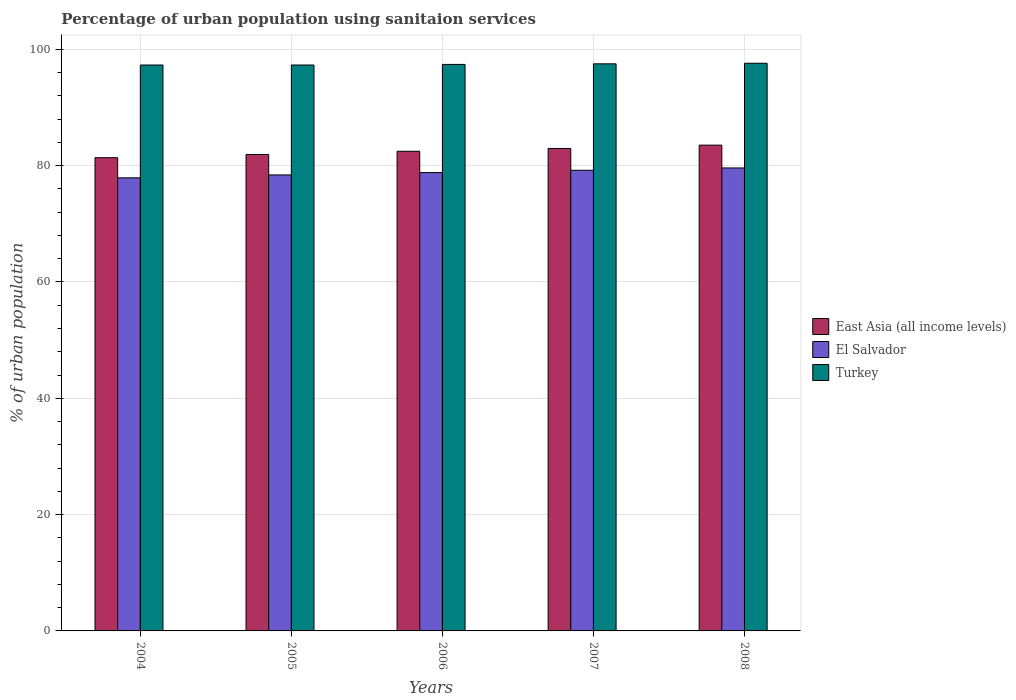How many different coloured bars are there?
Ensure brevity in your answer.  3. Are the number of bars per tick equal to the number of legend labels?
Offer a terse response. Yes. What is the percentage of urban population using sanitaion services in El Salvador in 2007?
Your answer should be very brief. 79.2. Across all years, what is the maximum percentage of urban population using sanitaion services in East Asia (all income levels)?
Keep it short and to the point. 83.52. Across all years, what is the minimum percentage of urban population using sanitaion services in Turkey?
Your response must be concise. 97.3. In which year was the percentage of urban population using sanitaion services in Turkey maximum?
Give a very brief answer. 2008. What is the total percentage of urban population using sanitaion services in East Asia (all income levels) in the graph?
Keep it short and to the point. 412.21. What is the difference between the percentage of urban population using sanitaion services in Turkey in 2007 and that in 2008?
Offer a terse response. -0.1. What is the difference between the percentage of urban population using sanitaion services in El Salvador in 2008 and the percentage of urban population using sanitaion services in East Asia (all income levels) in 2004?
Provide a succinct answer. -1.76. What is the average percentage of urban population using sanitaion services in East Asia (all income levels) per year?
Provide a succinct answer. 82.44. In the year 2005, what is the difference between the percentage of urban population using sanitaion services in Turkey and percentage of urban population using sanitaion services in East Asia (all income levels)?
Provide a succinct answer. 15.39. In how many years, is the percentage of urban population using sanitaion services in Turkey greater than 28 %?
Make the answer very short. 5. What is the ratio of the percentage of urban population using sanitaion services in East Asia (all income levels) in 2004 to that in 2008?
Make the answer very short. 0.97. Is the percentage of urban population using sanitaion services in El Salvador in 2004 less than that in 2007?
Provide a succinct answer. Yes. Is the difference between the percentage of urban population using sanitaion services in Turkey in 2006 and 2008 greater than the difference between the percentage of urban population using sanitaion services in East Asia (all income levels) in 2006 and 2008?
Ensure brevity in your answer.  Yes. What is the difference between the highest and the second highest percentage of urban population using sanitaion services in East Asia (all income levels)?
Your answer should be compact. 0.57. What is the difference between the highest and the lowest percentage of urban population using sanitaion services in Turkey?
Make the answer very short. 0.3. Is the sum of the percentage of urban population using sanitaion services in East Asia (all income levels) in 2005 and 2008 greater than the maximum percentage of urban population using sanitaion services in Turkey across all years?
Ensure brevity in your answer.  Yes. What does the 1st bar from the left in 2005 represents?
Your response must be concise. East Asia (all income levels). What does the 3rd bar from the right in 2005 represents?
Give a very brief answer. East Asia (all income levels). Are all the bars in the graph horizontal?
Your answer should be very brief. No. What is the difference between two consecutive major ticks on the Y-axis?
Your response must be concise. 20. How are the legend labels stacked?
Your response must be concise. Vertical. What is the title of the graph?
Provide a succinct answer. Percentage of urban population using sanitaion services. Does "San Marino" appear as one of the legend labels in the graph?
Keep it short and to the point. No. What is the label or title of the Y-axis?
Provide a short and direct response. % of urban population. What is the % of urban population of East Asia (all income levels) in 2004?
Keep it short and to the point. 81.36. What is the % of urban population of El Salvador in 2004?
Keep it short and to the point. 77.9. What is the % of urban population in Turkey in 2004?
Keep it short and to the point. 97.3. What is the % of urban population in East Asia (all income levels) in 2005?
Your answer should be compact. 81.91. What is the % of urban population in El Salvador in 2005?
Ensure brevity in your answer.  78.4. What is the % of urban population in Turkey in 2005?
Offer a terse response. 97.3. What is the % of urban population in East Asia (all income levels) in 2006?
Offer a very short reply. 82.47. What is the % of urban population in El Salvador in 2006?
Provide a succinct answer. 78.8. What is the % of urban population of Turkey in 2006?
Give a very brief answer. 97.4. What is the % of urban population of East Asia (all income levels) in 2007?
Offer a very short reply. 82.95. What is the % of urban population of El Salvador in 2007?
Your response must be concise. 79.2. What is the % of urban population in Turkey in 2007?
Your answer should be very brief. 97.5. What is the % of urban population in East Asia (all income levels) in 2008?
Provide a succinct answer. 83.52. What is the % of urban population in El Salvador in 2008?
Give a very brief answer. 79.6. What is the % of urban population in Turkey in 2008?
Your response must be concise. 97.6. Across all years, what is the maximum % of urban population of East Asia (all income levels)?
Offer a very short reply. 83.52. Across all years, what is the maximum % of urban population in El Salvador?
Ensure brevity in your answer.  79.6. Across all years, what is the maximum % of urban population of Turkey?
Provide a succinct answer. 97.6. Across all years, what is the minimum % of urban population of East Asia (all income levels)?
Offer a terse response. 81.36. Across all years, what is the minimum % of urban population of El Salvador?
Provide a short and direct response. 77.9. Across all years, what is the minimum % of urban population in Turkey?
Your answer should be compact. 97.3. What is the total % of urban population in East Asia (all income levels) in the graph?
Offer a very short reply. 412.21. What is the total % of urban population in El Salvador in the graph?
Make the answer very short. 393.9. What is the total % of urban population of Turkey in the graph?
Your answer should be very brief. 487.1. What is the difference between the % of urban population of East Asia (all income levels) in 2004 and that in 2005?
Ensure brevity in your answer.  -0.55. What is the difference between the % of urban population of El Salvador in 2004 and that in 2005?
Ensure brevity in your answer.  -0.5. What is the difference between the % of urban population in East Asia (all income levels) in 2004 and that in 2006?
Ensure brevity in your answer.  -1.11. What is the difference between the % of urban population in El Salvador in 2004 and that in 2006?
Your response must be concise. -0.9. What is the difference between the % of urban population in Turkey in 2004 and that in 2006?
Keep it short and to the point. -0.1. What is the difference between the % of urban population in East Asia (all income levels) in 2004 and that in 2007?
Give a very brief answer. -1.59. What is the difference between the % of urban population of East Asia (all income levels) in 2004 and that in 2008?
Keep it short and to the point. -2.16. What is the difference between the % of urban population in El Salvador in 2004 and that in 2008?
Provide a succinct answer. -1.7. What is the difference between the % of urban population of Turkey in 2004 and that in 2008?
Provide a short and direct response. -0.3. What is the difference between the % of urban population of East Asia (all income levels) in 2005 and that in 2006?
Provide a short and direct response. -0.55. What is the difference between the % of urban population of East Asia (all income levels) in 2005 and that in 2007?
Ensure brevity in your answer.  -1.04. What is the difference between the % of urban population of Turkey in 2005 and that in 2007?
Your response must be concise. -0.2. What is the difference between the % of urban population in East Asia (all income levels) in 2005 and that in 2008?
Provide a short and direct response. -1.61. What is the difference between the % of urban population in Turkey in 2005 and that in 2008?
Provide a short and direct response. -0.3. What is the difference between the % of urban population of East Asia (all income levels) in 2006 and that in 2007?
Provide a short and direct response. -0.49. What is the difference between the % of urban population in East Asia (all income levels) in 2006 and that in 2008?
Offer a very short reply. -1.05. What is the difference between the % of urban population in East Asia (all income levels) in 2007 and that in 2008?
Make the answer very short. -0.57. What is the difference between the % of urban population of El Salvador in 2007 and that in 2008?
Give a very brief answer. -0.4. What is the difference between the % of urban population of Turkey in 2007 and that in 2008?
Offer a terse response. -0.1. What is the difference between the % of urban population in East Asia (all income levels) in 2004 and the % of urban population in El Salvador in 2005?
Your answer should be very brief. 2.96. What is the difference between the % of urban population of East Asia (all income levels) in 2004 and the % of urban population of Turkey in 2005?
Your answer should be very brief. -15.94. What is the difference between the % of urban population in El Salvador in 2004 and the % of urban population in Turkey in 2005?
Give a very brief answer. -19.4. What is the difference between the % of urban population of East Asia (all income levels) in 2004 and the % of urban population of El Salvador in 2006?
Keep it short and to the point. 2.56. What is the difference between the % of urban population of East Asia (all income levels) in 2004 and the % of urban population of Turkey in 2006?
Make the answer very short. -16.04. What is the difference between the % of urban population in El Salvador in 2004 and the % of urban population in Turkey in 2006?
Your answer should be compact. -19.5. What is the difference between the % of urban population of East Asia (all income levels) in 2004 and the % of urban population of El Salvador in 2007?
Ensure brevity in your answer.  2.16. What is the difference between the % of urban population of East Asia (all income levels) in 2004 and the % of urban population of Turkey in 2007?
Make the answer very short. -16.14. What is the difference between the % of urban population in El Salvador in 2004 and the % of urban population in Turkey in 2007?
Keep it short and to the point. -19.6. What is the difference between the % of urban population in East Asia (all income levels) in 2004 and the % of urban population in El Salvador in 2008?
Your response must be concise. 1.76. What is the difference between the % of urban population in East Asia (all income levels) in 2004 and the % of urban population in Turkey in 2008?
Offer a very short reply. -16.24. What is the difference between the % of urban population of El Salvador in 2004 and the % of urban population of Turkey in 2008?
Make the answer very short. -19.7. What is the difference between the % of urban population in East Asia (all income levels) in 2005 and the % of urban population in El Salvador in 2006?
Provide a succinct answer. 3.11. What is the difference between the % of urban population of East Asia (all income levels) in 2005 and the % of urban population of Turkey in 2006?
Offer a terse response. -15.49. What is the difference between the % of urban population of El Salvador in 2005 and the % of urban population of Turkey in 2006?
Your response must be concise. -19. What is the difference between the % of urban population in East Asia (all income levels) in 2005 and the % of urban population in El Salvador in 2007?
Give a very brief answer. 2.71. What is the difference between the % of urban population of East Asia (all income levels) in 2005 and the % of urban population of Turkey in 2007?
Your answer should be compact. -15.59. What is the difference between the % of urban population in El Salvador in 2005 and the % of urban population in Turkey in 2007?
Provide a short and direct response. -19.1. What is the difference between the % of urban population in East Asia (all income levels) in 2005 and the % of urban population in El Salvador in 2008?
Ensure brevity in your answer.  2.31. What is the difference between the % of urban population in East Asia (all income levels) in 2005 and the % of urban population in Turkey in 2008?
Offer a terse response. -15.69. What is the difference between the % of urban population in El Salvador in 2005 and the % of urban population in Turkey in 2008?
Offer a terse response. -19.2. What is the difference between the % of urban population of East Asia (all income levels) in 2006 and the % of urban population of El Salvador in 2007?
Ensure brevity in your answer.  3.27. What is the difference between the % of urban population of East Asia (all income levels) in 2006 and the % of urban population of Turkey in 2007?
Your response must be concise. -15.03. What is the difference between the % of urban population of El Salvador in 2006 and the % of urban population of Turkey in 2007?
Ensure brevity in your answer.  -18.7. What is the difference between the % of urban population in East Asia (all income levels) in 2006 and the % of urban population in El Salvador in 2008?
Ensure brevity in your answer.  2.87. What is the difference between the % of urban population in East Asia (all income levels) in 2006 and the % of urban population in Turkey in 2008?
Keep it short and to the point. -15.13. What is the difference between the % of urban population of El Salvador in 2006 and the % of urban population of Turkey in 2008?
Your answer should be compact. -18.8. What is the difference between the % of urban population in East Asia (all income levels) in 2007 and the % of urban population in El Salvador in 2008?
Ensure brevity in your answer.  3.35. What is the difference between the % of urban population in East Asia (all income levels) in 2007 and the % of urban population in Turkey in 2008?
Offer a very short reply. -14.65. What is the difference between the % of urban population of El Salvador in 2007 and the % of urban population of Turkey in 2008?
Keep it short and to the point. -18.4. What is the average % of urban population of East Asia (all income levels) per year?
Offer a terse response. 82.44. What is the average % of urban population of El Salvador per year?
Give a very brief answer. 78.78. What is the average % of urban population in Turkey per year?
Give a very brief answer. 97.42. In the year 2004, what is the difference between the % of urban population in East Asia (all income levels) and % of urban population in El Salvador?
Your answer should be compact. 3.46. In the year 2004, what is the difference between the % of urban population of East Asia (all income levels) and % of urban population of Turkey?
Keep it short and to the point. -15.94. In the year 2004, what is the difference between the % of urban population in El Salvador and % of urban population in Turkey?
Your response must be concise. -19.4. In the year 2005, what is the difference between the % of urban population in East Asia (all income levels) and % of urban population in El Salvador?
Offer a very short reply. 3.51. In the year 2005, what is the difference between the % of urban population of East Asia (all income levels) and % of urban population of Turkey?
Your answer should be compact. -15.39. In the year 2005, what is the difference between the % of urban population of El Salvador and % of urban population of Turkey?
Your answer should be very brief. -18.9. In the year 2006, what is the difference between the % of urban population in East Asia (all income levels) and % of urban population in El Salvador?
Offer a very short reply. 3.67. In the year 2006, what is the difference between the % of urban population of East Asia (all income levels) and % of urban population of Turkey?
Your response must be concise. -14.93. In the year 2006, what is the difference between the % of urban population of El Salvador and % of urban population of Turkey?
Your answer should be compact. -18.6. In the year 2007, what is the difference between the % of urban population of East Asia (all income levels) and % of urban population of El Salvador?
Give a very brief answer. 3.75. In the year 2007, what is the difference between the % of urban population in East Asia (all income levels) and % of urban population in Turkey?
Provide a short and direct response. -14.55. In the year 2007, what is the difference between the % of urban population of El Salvador and % of urban population of Turkey?
Offer a very short reply. -18.3. In the year 2008, what is the difference between the % of urban population in East Asia (all income levels) and % of urban population in El Salvador?
Provide a succinct answer. 3.92. In the year 2008, what is the difference between the % of urban population of East Asia (all income levels) and % of urban population of Turkey?
Your response must be concise. -14.08. In the year 2008, what is the difference between the % of urban population in El Salvador and % of urban population in Turkey?
Offer a very short reply. -18. What is the ratio of the % of urban population of Turkey in 2004 to that in 2005?
Give a very brief answer. 1. What is the ratio of the % of urban population in East Asia (all income levels) in 2004 to that in 2006?
Offer a terse response. 0.99. What is the ratio of the % of urban population of El Salvador in 2004 to that in 2006?
Your answer should be very brief. 0.99. What is the ratio of the % of urban population in East Asia (all income levels) in 2004 to that in 2007?
Give a very brief answer. 0.98. What is the ratio of the % of urban population in El Salvador in 2004 to that in 2007?
Provide a succinct answer. 0.98. What is the ratio of the % of urban population of East Asia (all income levels) in 2004 to that in 2008?
Ensure brevity in your answer.  0.97. What is the ratio of the % of urban population of El Salvador in 2004 to that in 2008?
Provide a short and direct response. 0.98. What is the ratio of the % of urban population of Turkey in 2004 to that in 2008?
Your answer should be very brief. 1. What is the ratio of the % of urban population in El Salvador in 2005 to that in 2006?
Your response must be concise. 0.99. What is the ratio of the % of urban population of East Asia (all income levels) in 2005 to that in 2007?
Your response must be concise. 0.99. What is the ratio of the % of urban population of Turkey in 2005 to that in 2007?
Provide a succinct answer. 1. What is the ratio of the % of urban population of East Asia (all income levels) in 2005 to that in 2008?
Your answer should be very brief. 0.98. What is the ratio of the % of urban population of El Salvador in 2005 to that in 2008?
Provide a succinct answer. 0.98. What is the ratio of the % of urban population of Turkey in 2005 to that in 2008?
Offer a very short reply. 1. What is the ratio of the % of urban population in Turkey in 2006 to that in 2007?
Your answer should be very brief. 1. What is the ratio of the % of urban population of East Asia (all income levels) in 2006 to that in 2008?
Your answer should be very brief. 0.99. What is the ratio of the % of urban population of Turkey in 2006 to that in 2008?
Offer a terse response. 1. What is the ratio of the % of urban population of El Salvador in 2007 to that in 2008?
Provide a short and direct response. 0.99. What is the difference between the highest and the second highest % of urban population of East Asia (all income levels)?
Your answer should be very brief. 0.57. What is the difference between the highest and the second highest % of urban population of El Salvador?
Give a very brief answer. 0.4. What is the difference between the highest and the second highest % of urban population of Turkey?
Make the answer very short. 0.1. What is the difference between the highest and the lowest % of urban population in East Asia (all income levels)?
Ensure brevity in your answer.  2.16. 